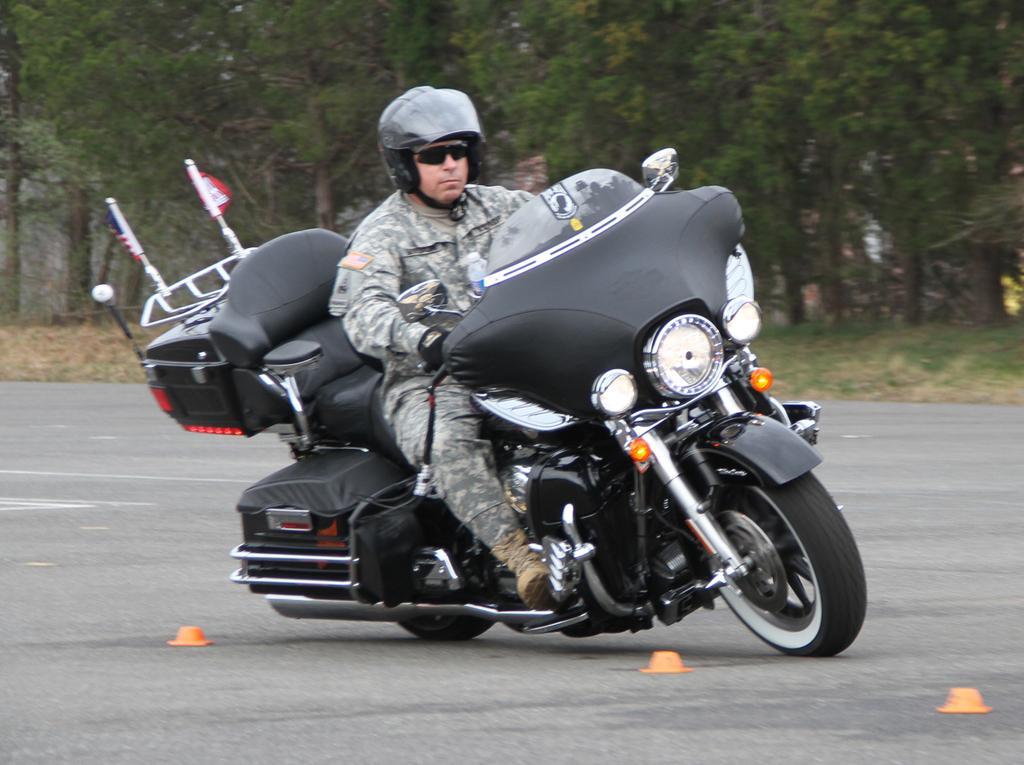In one or two sentences, can you explain what this image depicts? Here in this picture we can see a man riding a bike. This man is a policeman. He is wearing a goggles and he is wearing a helmet on his head. To that bike there is a light. There is a road. And in the background there are some trees. 